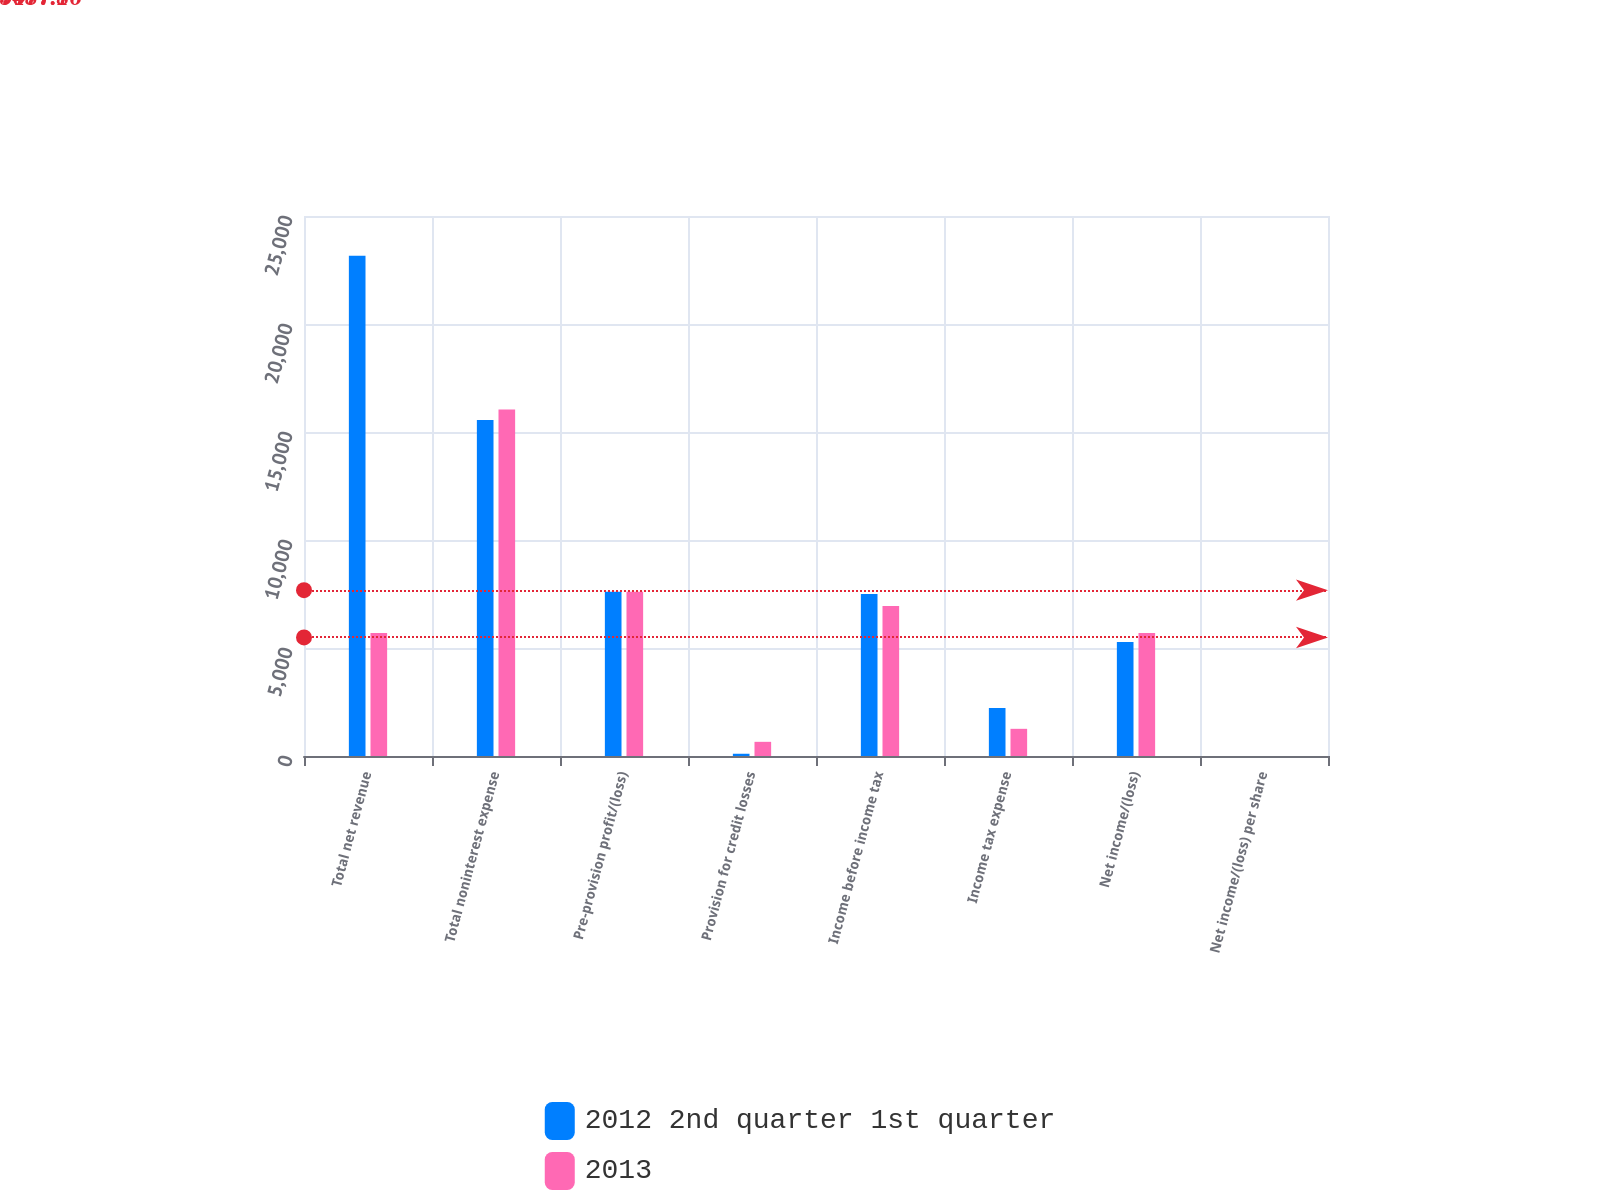<chart> <loc_0><loc_0><loc_500><loc_500><stacked_bar_chart><ecel><fcel>Total net revenue<fcel>Total noninterest expense<fcel>Pre-provision profit/(loss)<fcel>Provision for credit losses<fcel>Income before income tax<fcel>Income tax expense<fcel>Net income/(loss)<fcel>Net income/(loss) per share<nl><fcel>2012 2nd quarter 1st quarter<fcel>23156<fcel>15552<fcel>7604<fcel>104<fcel>7500<fcel>2222<fcel>5278<fcel>1.31<nl><fcel>2013<fcel>5692<fcel>16047<fcel>7606<fcel>656<fcel>6950<fcel>1258<fcel>5692<fcel>1.4<nl></chart> 